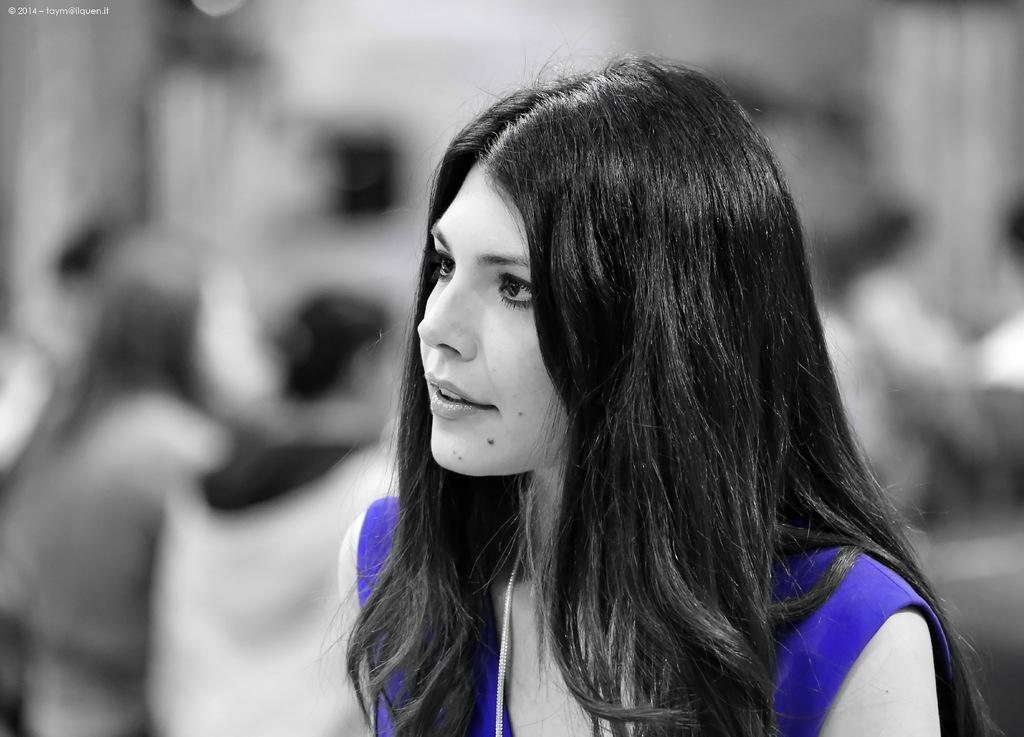What is the main subject of the image? The main subject of the image is a woman sitting in the middle. What is the woman doing in the image? The woman is watching something in the image. Are there any other people in the image? Yes, there are people sitting behind her. Can you describe the background of the image? The background of the image is blurred. How much does the drawer weigh in the image? There is no drawer present in the image, so it is not possible to determine its weight. 